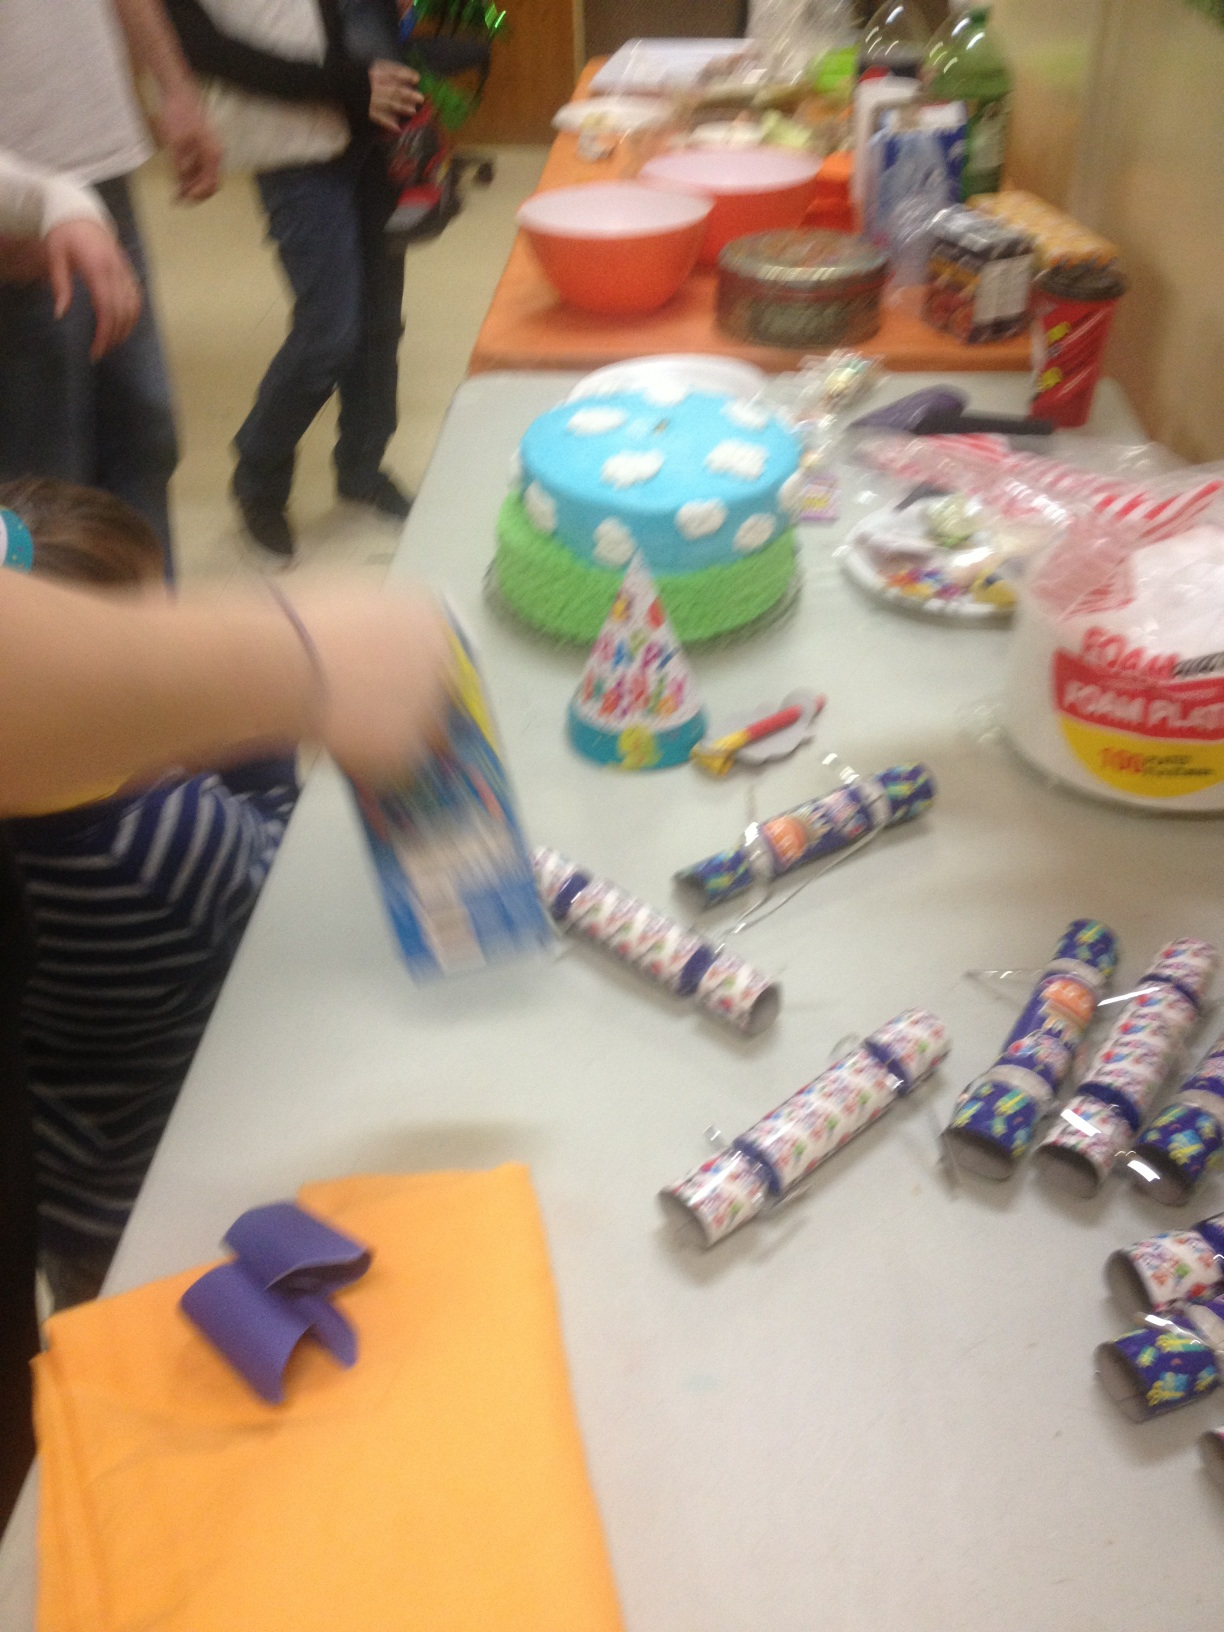Can you describe the cake on the table? The cake is round and intricately decorated with a bright blue and green frosting, featuring white fluffy clouds or bubbles, suggesting a theme possibly inspired by the sky or a whimsical landscape. 